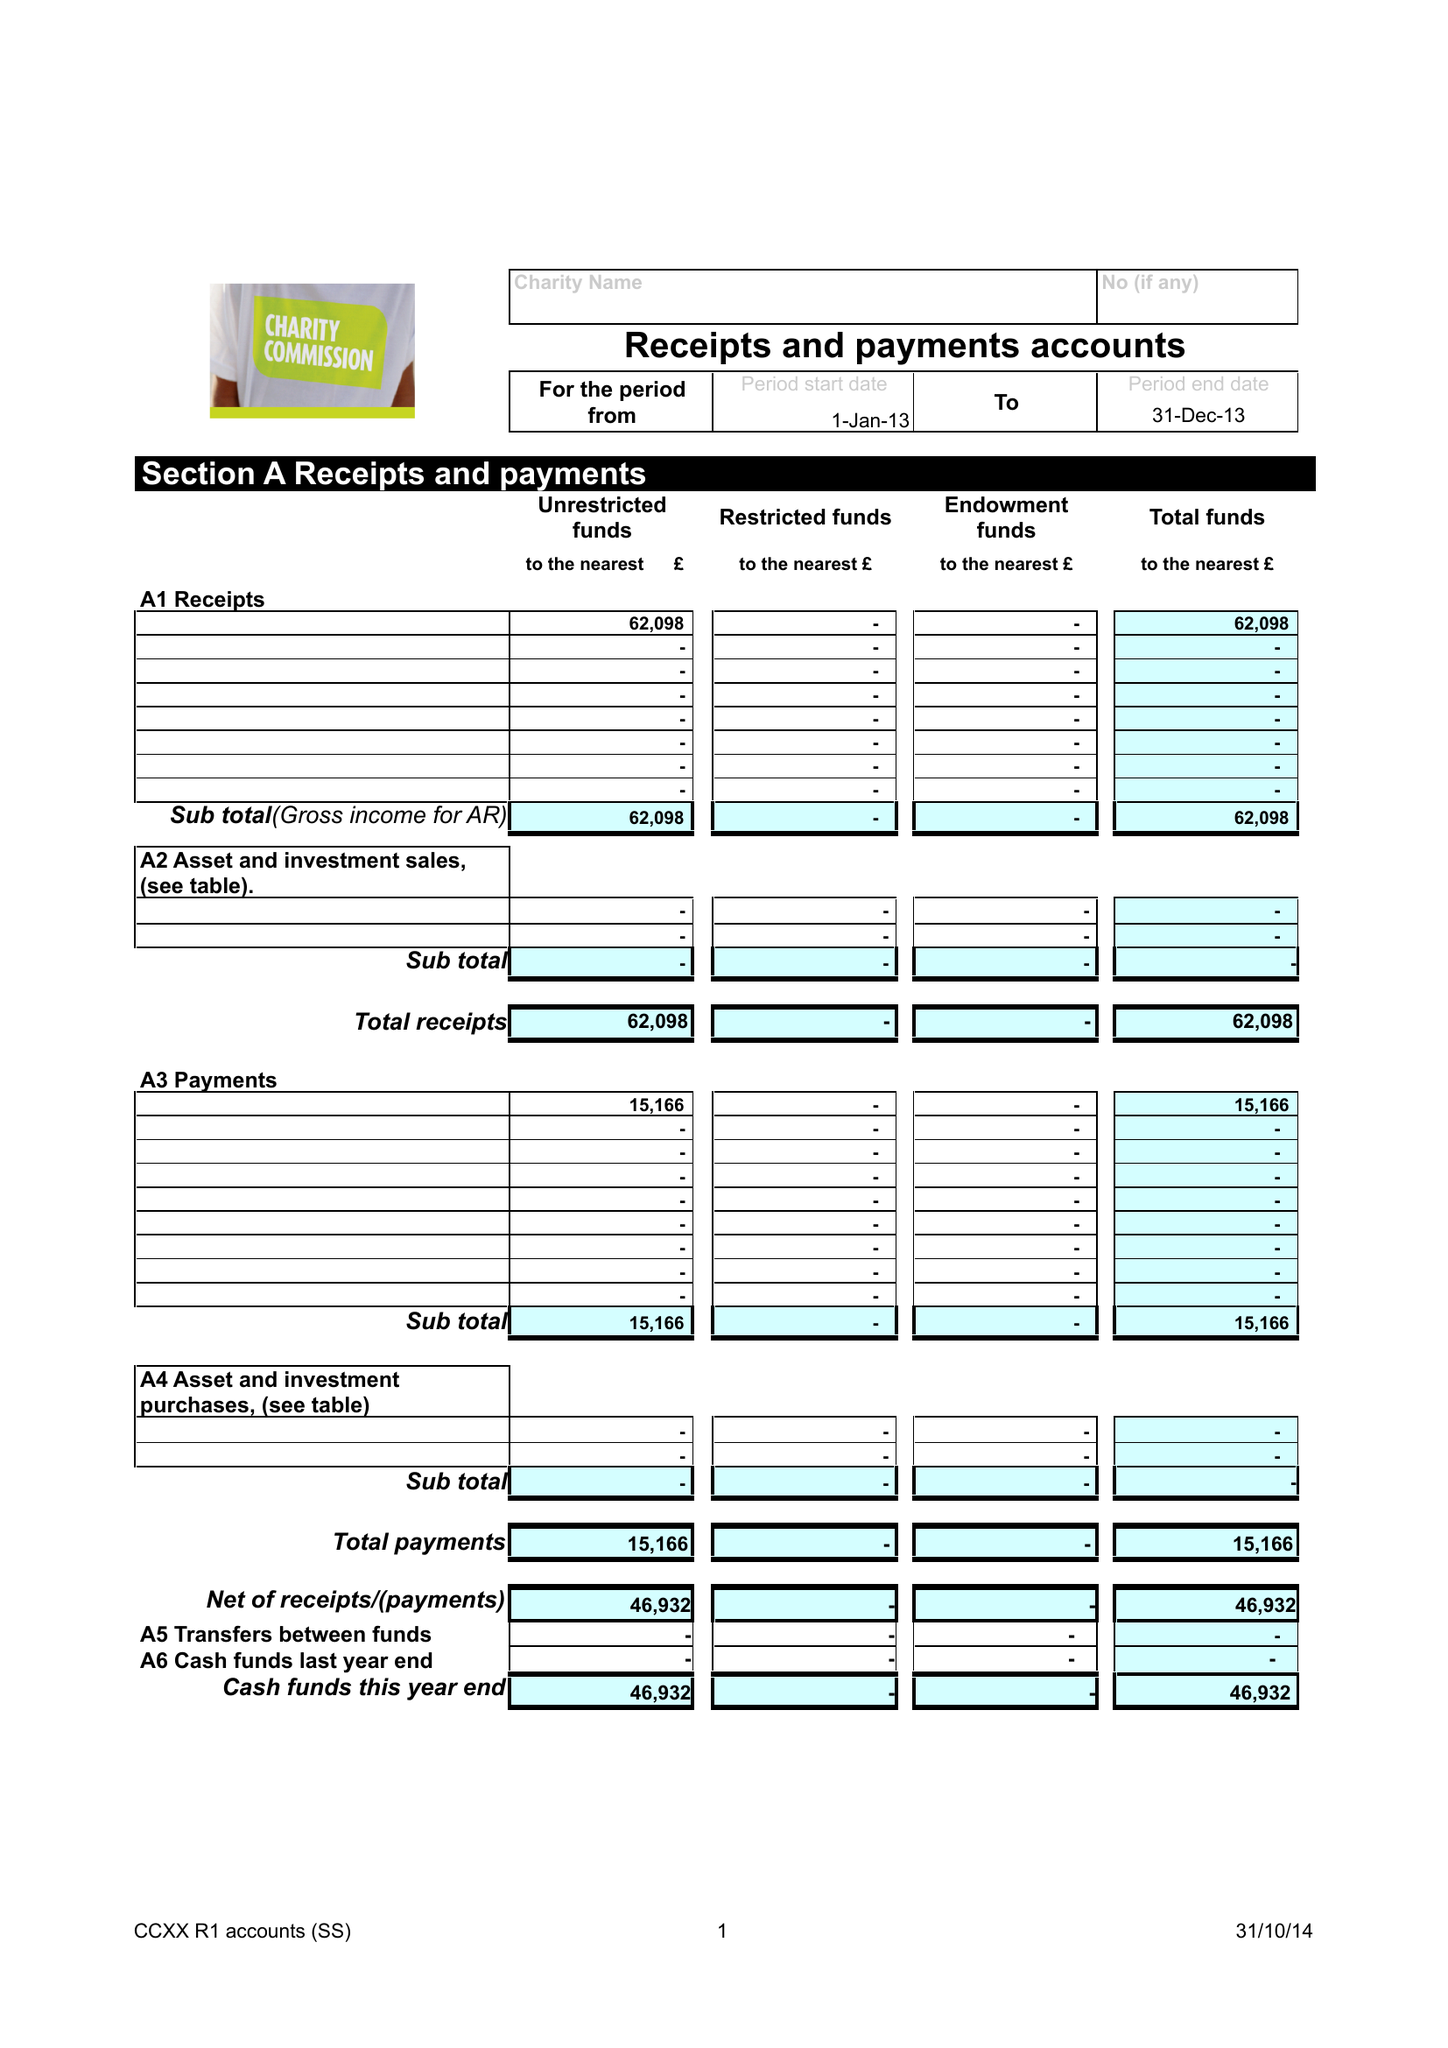What is the value for the address__postcode?
Answer the question using a single word or phrase. SA33 6JA 